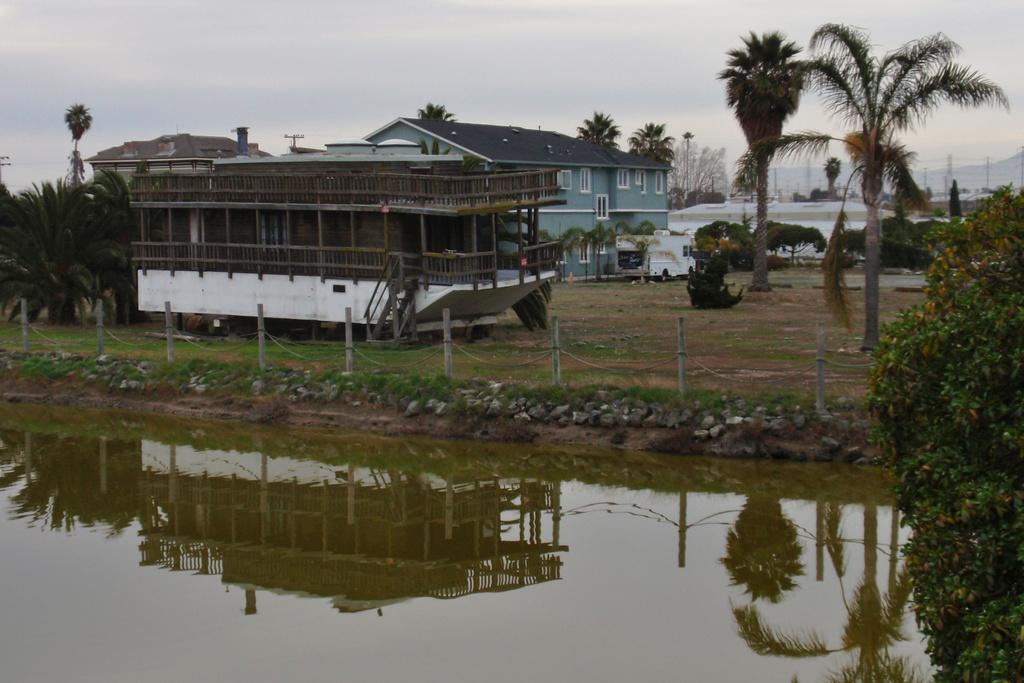Please provide a concise description of this image. In this image, we can see some trees and roof houses. There is a wooden house and vehicle in the middle of the image. There are poles beside the lake. At the top of the image, we can see the sky. 